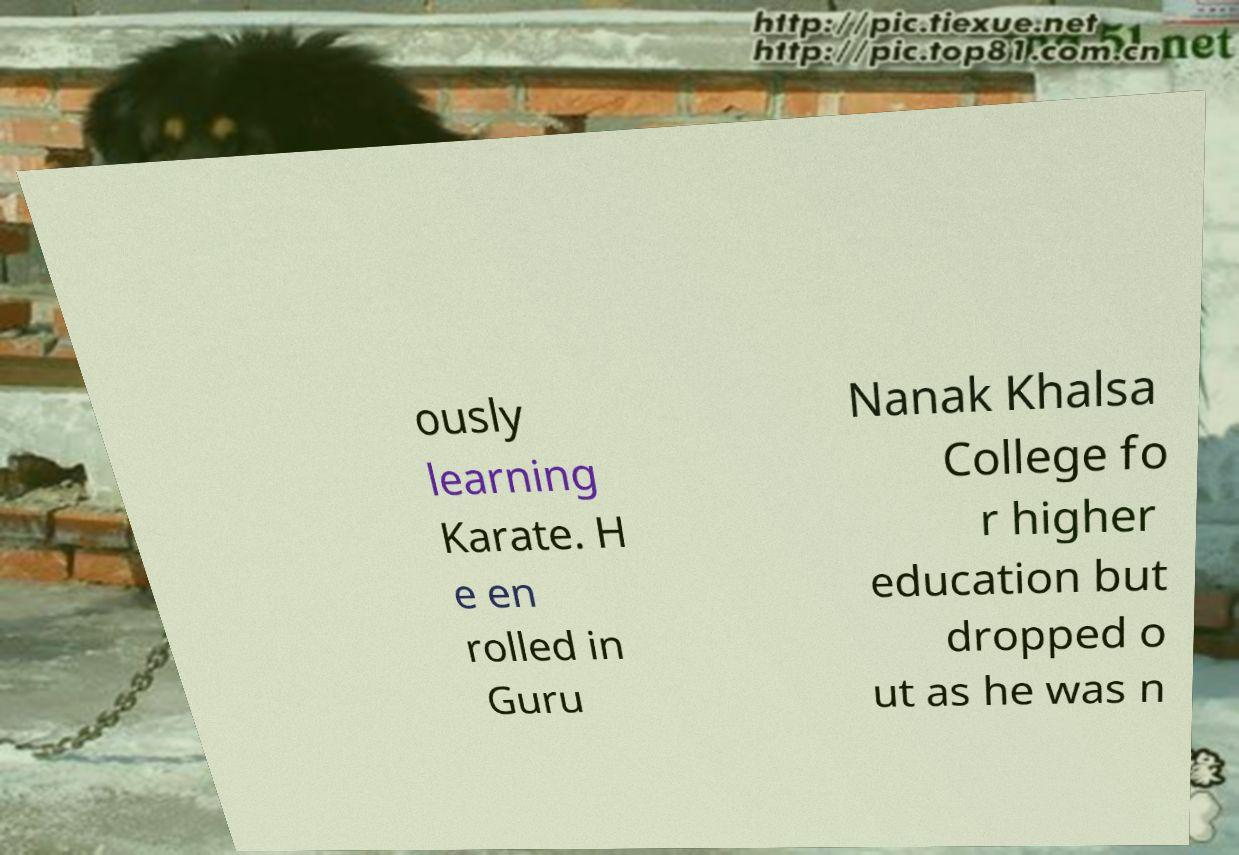What messages or text are displayed in this image? I need them in a readable, typed format. ously learning Karate. H e en rolled in Guru Nanak Khalsa College fo r higher education but dropped o ut as he was n 